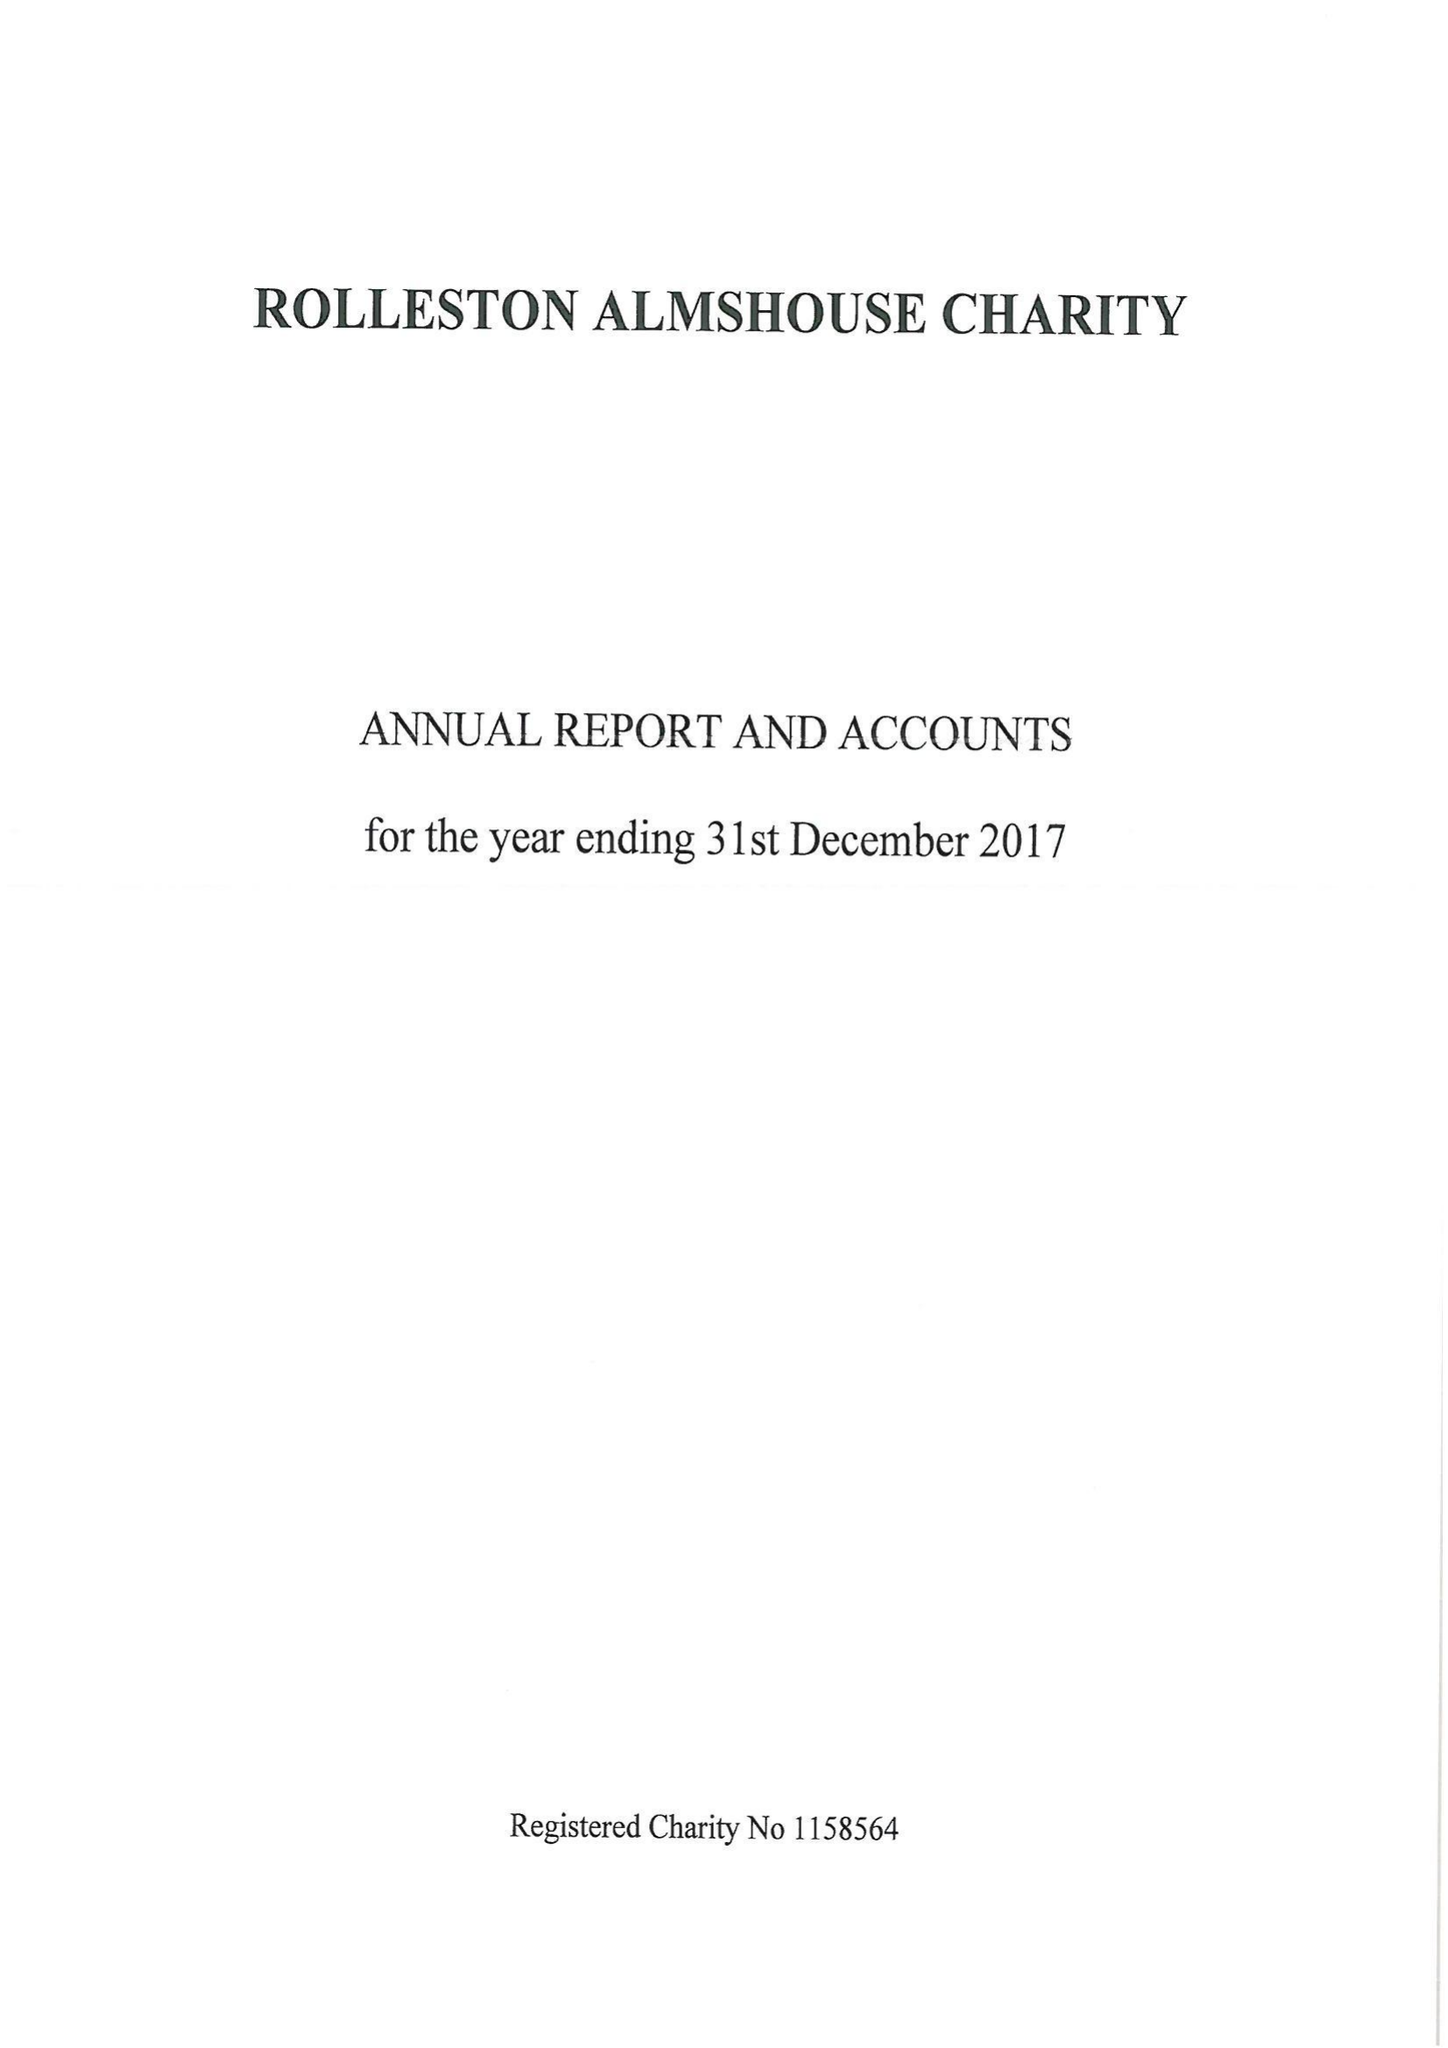What is the value for the income_annually_in_british_pounds?
Answer the question using a single word or phrase. 35495.00 